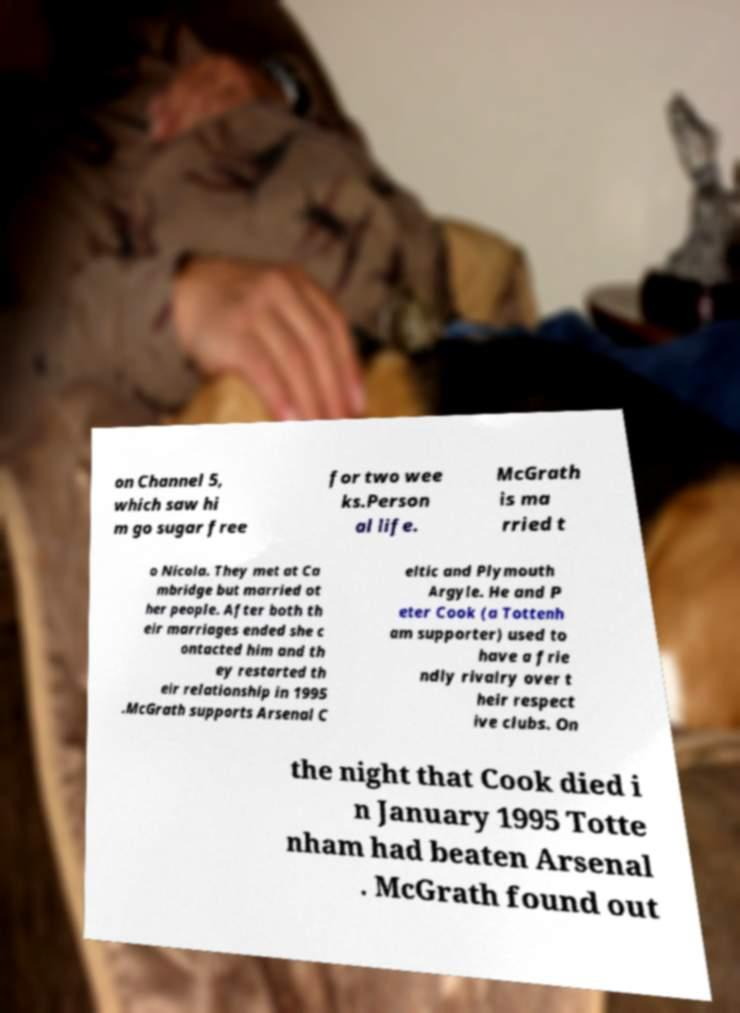For documentation purposes, I need the text within this image transcribed. Could you provide that? on Channel 5, which saw hi m go sugar free for two wee ks.Person al life. McGrath is ma rried t o Nicola. They met at Ca mbridge but married ot her people. After both th eir marriages ended she c ontacted him and th ey restarted th eir relationship in 1995 .McGrath supports Arsenal C eltic and Plymouth Argyle. He and P eter Cook (a Tottenh am supporter) used to have a frie ndly rivalry over t heir respect ive clubs. On the night that Cook died i n January 1995 Totte nham had beaten Arsenal . McGrath found out 